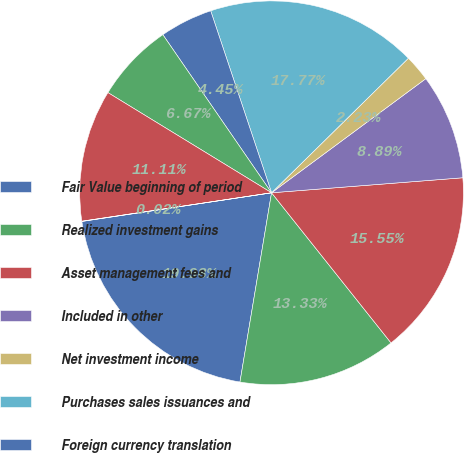Convert chart. <chart><loc_0><loc_0><loc_500><loc_500><pie_chart><fcel>Fair Value beginning of period<fcel>Realized investment gains<fcel>Asset management fees and<fcel>Included in other<fcel>Net investment income<fcel>Purchases sales issuances and<fcel>Foreign currency translation<fcel>Other(1)<fcel>Transfers into Level 3(2)<fcel>Transfers out of Level 3(2)<nl><fcel>19.98%<fcel>13.33%<fcel>15.55%<fcel>8.89%<fcel>2.23%<fcel>17.77%<fcel>4.45%<fcel>6.67%<fcel>11.11%<fcel>0.02%<nl></chart> 